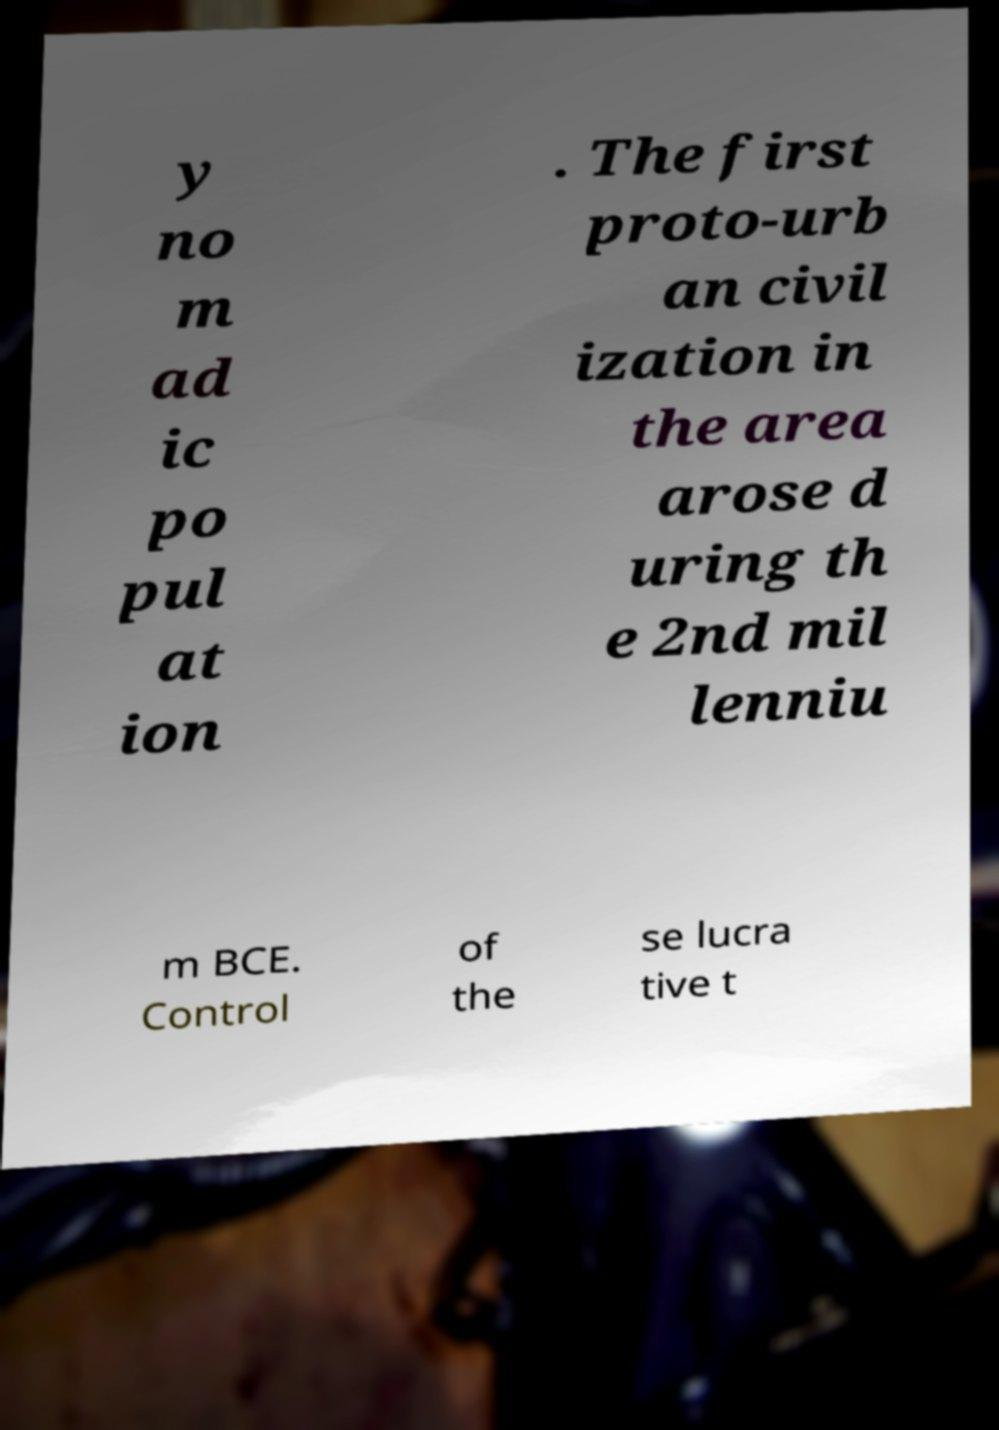Can you read and provide the text displayed in the image?This photo seems to have some interesting text. Can you extract and type it out for me? y no m ad ic po pul at ion . The first proto-urb an civil ization in the area arose d uring th e 2nd mil lenniu m BCE. Control of the se lucra tive t 